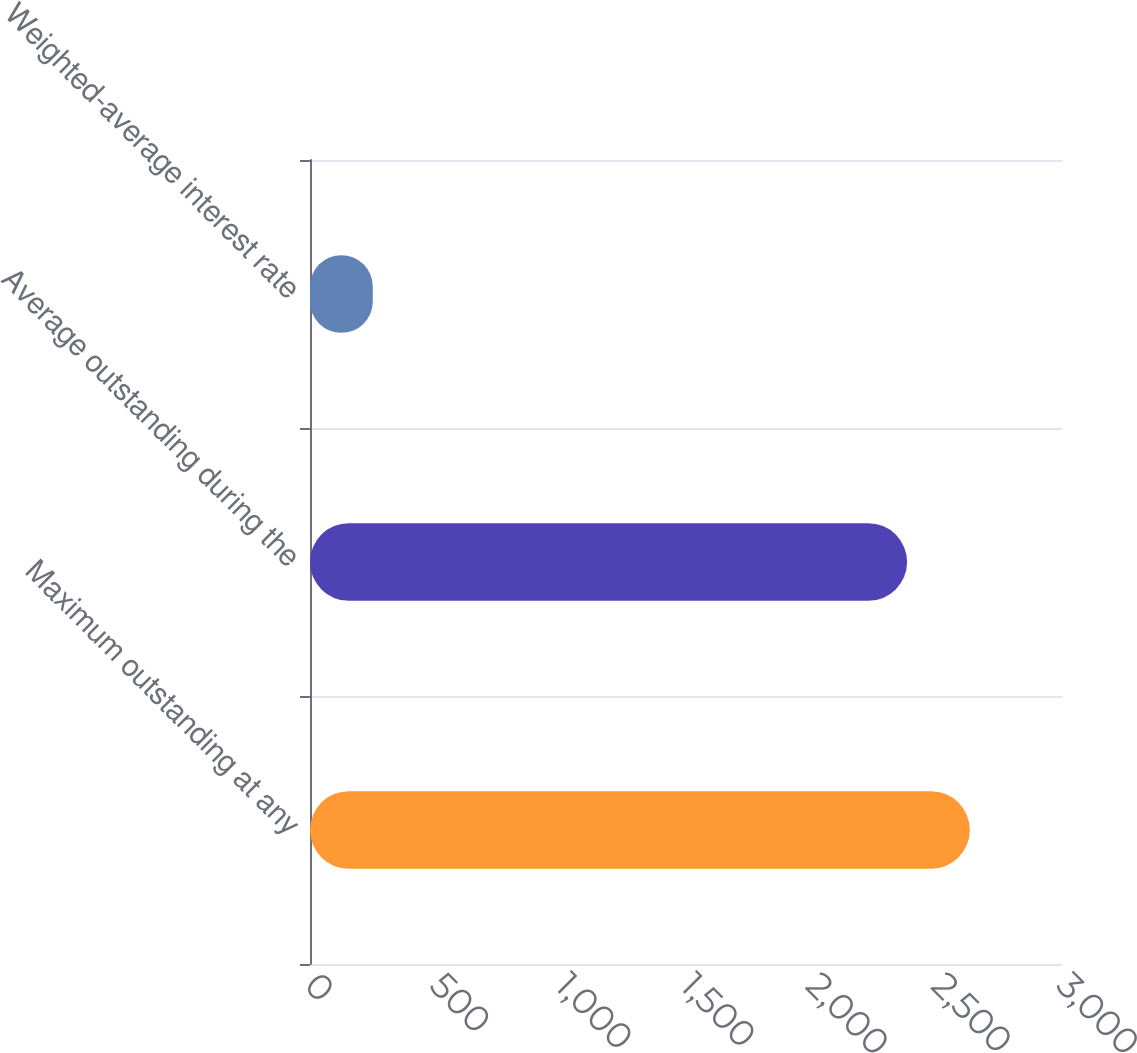Convert chart to OTSL. <chart><loc_0><loc_0><loc_500><loc_500><bar_chart><fcel>Maximum outstanding at any<fcel>Average outstanding during the<fcel>Weighted-average interest rate<nl><fcel>2632.28<fcel>2382<fcel>250.5<nl></chart> 